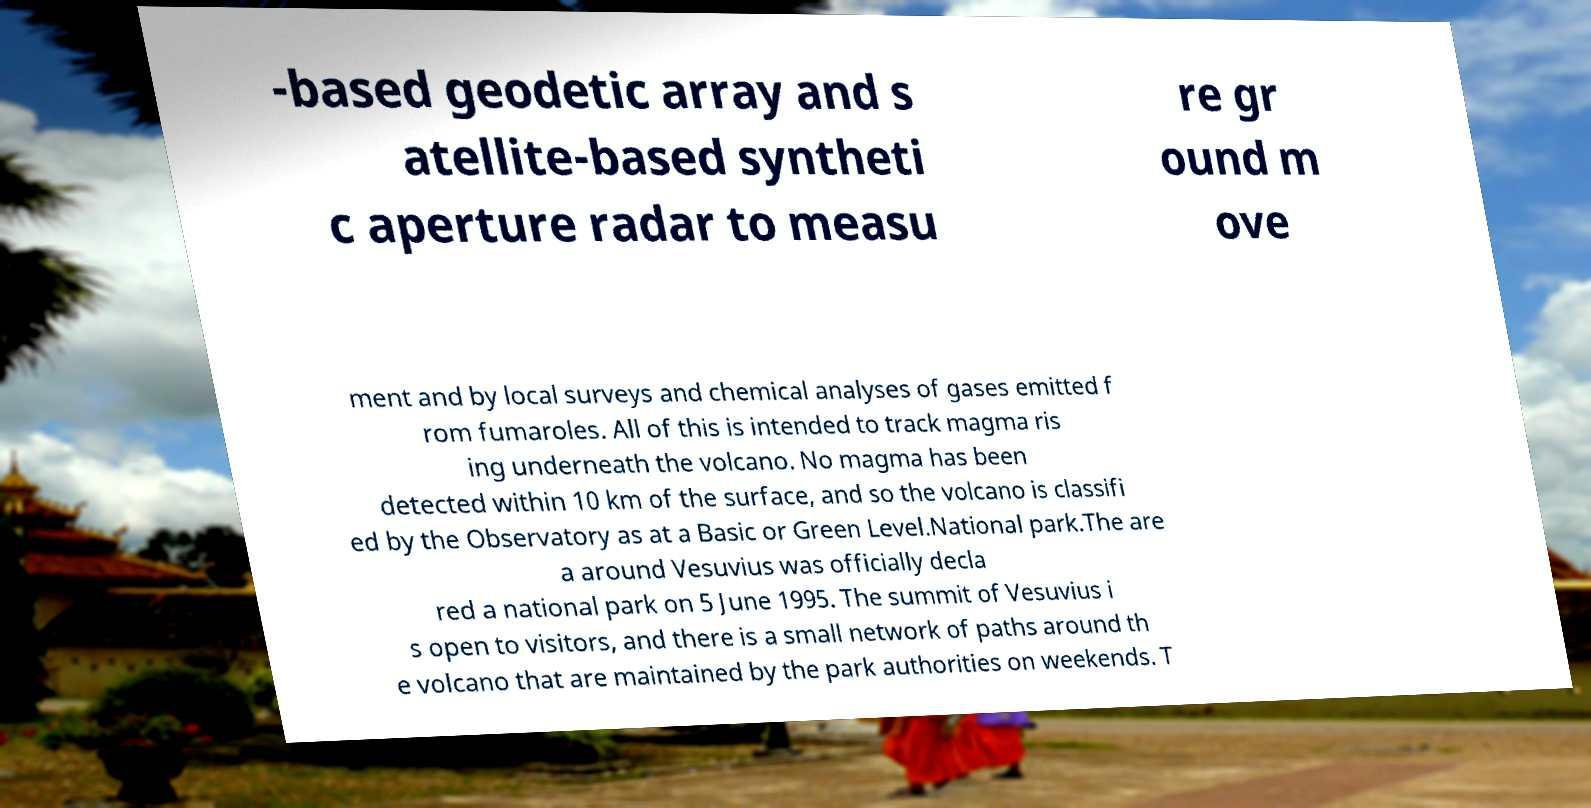I need the written content from this picture converted into text. Can you do that? -based geodetic array and s atellite-based syntheti c aperture radar to measu re gr ound m ove ment and by local surveys and chemical analyses of gases emitted f rom fumaroles. All of this is intended to track magma ris ing underneath the volcano. No magma has been detected within 10 km of the surface, and so the volcano is classifi ed by the Observatory as at a Basic or Green Level.National park.The are a around Vesuvius was officially decla red a national park on 5 June 1995. The summit of Vesuvius i s open to visitors, and there is a small network of paths around th e volcano that are maintained by the park authorities on weekends. T 